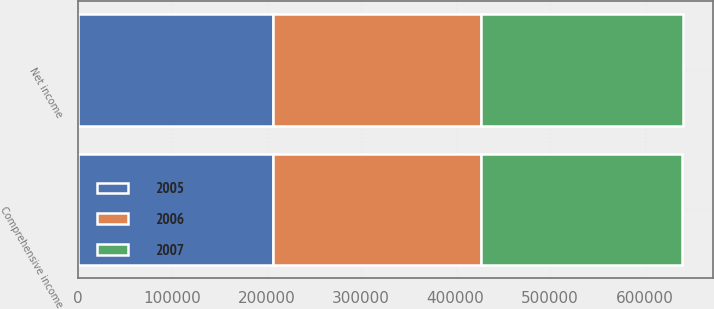Convert chart. <chart><loc_0><loc_0><loc_500><loc_500><stacked_bar_chart><ecel><fcel>Net income<fcel>Comprehensive income<nl><fcel>2007<fcel>213134<fcel>212289<nl><fcel>2006<fcel>219952<fcel>219804<nl><fcel>2005<fcel>207311<fcel>207311<nl></chart> 